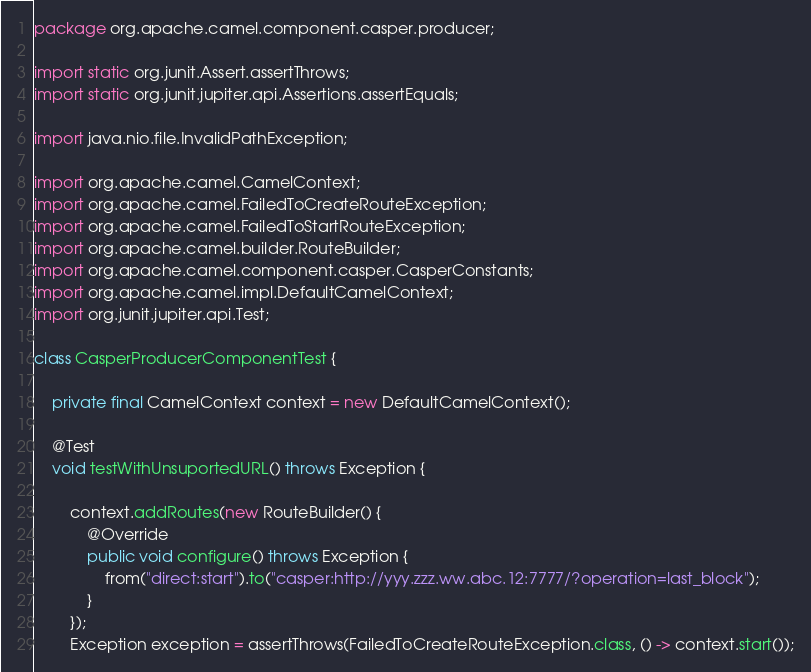Convert code to text. <code><loc_0><loc_0><loc_500><loc_500><_Java_>package org.apache.camel.component.casper.producer;

import static org.junit.Assert.assertThrows;
import static org.junit.jupiter.api.Assertions.assertEquals;

import java.nio.file.InvalidPathException;

import org.apache.camel.CamelContext;
import org.apache.camel.FailedToCreateRouteException;
import org.apache.camel.FailedToStartRouteException;
import org.apache.camel.builder.RouteBuilder;
import org.apache.camel.component.casper.CasperConstants;
import org.apache.camel.impl.DefaultCamelContext;
import org.junit.jupiter.api.Test;

class CasperProducerComponentTest {

	private final CamelContext context = new DefaultCamelContext();

	@Test
	void testWithUnsuportedURL() throws Exception {

		context.addRoutes(new RouteBuilder() {
			@Override
			public void configure() throws Exception {
				from("direct:start").to("casper:http://yyy.zzz.ww.abc.12:7777/?operation=last_block");
			}
		});
		Exception exception = assertThrows(FailedToCreateRouteException.class, () -> context.start());</code> 